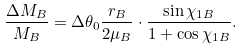Convert formula to latex. <formula><loc_0><loc_0><loc_500><loc_500>\frac { \Delta M _ { B } } { M _ { B } } = \Delta \theta _ { 0 } \frac { r _ { B } } { 2 \mu _ { B } } \cdot \frac { \sin \chi _ { 1 B } } { 1 + \cos \chi _ { 1 B } } .</formula> 